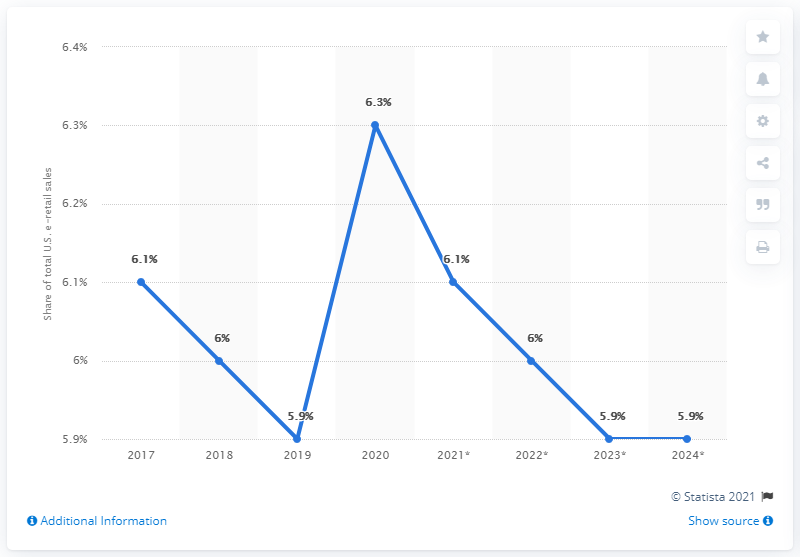Indicate a few pertinent items in this graphic. By 2024, physical media sales are projected to represent approximately 5.9% of total retail e-commerce sales in the US. 